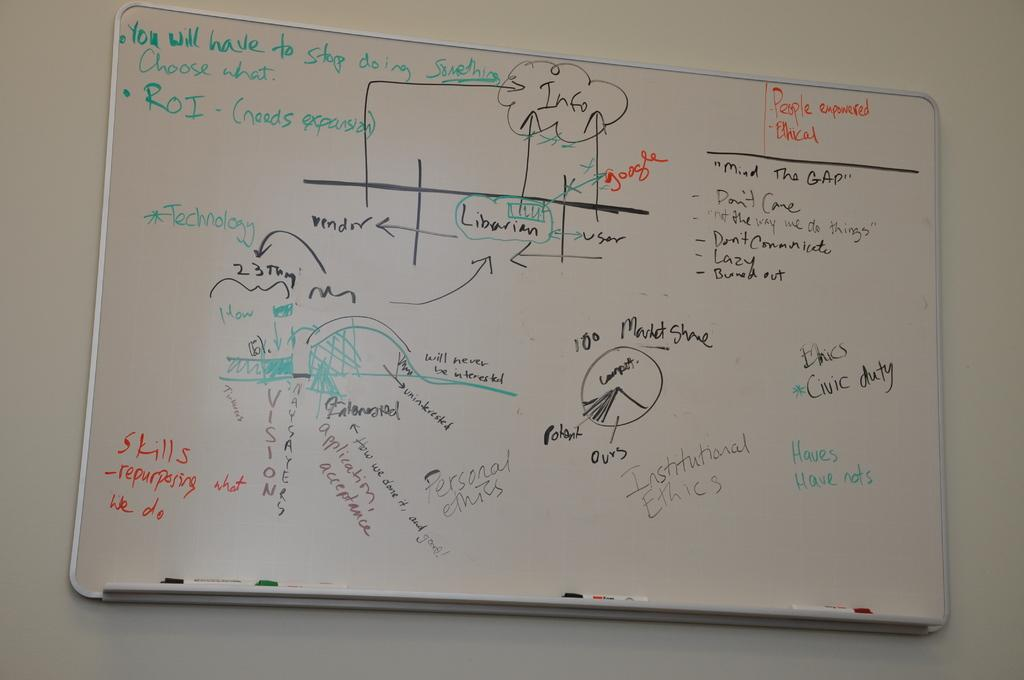Provide a one-sentence caption for the provided image. A whiteboard says that you will have to stop doing something, and you should choose what. 